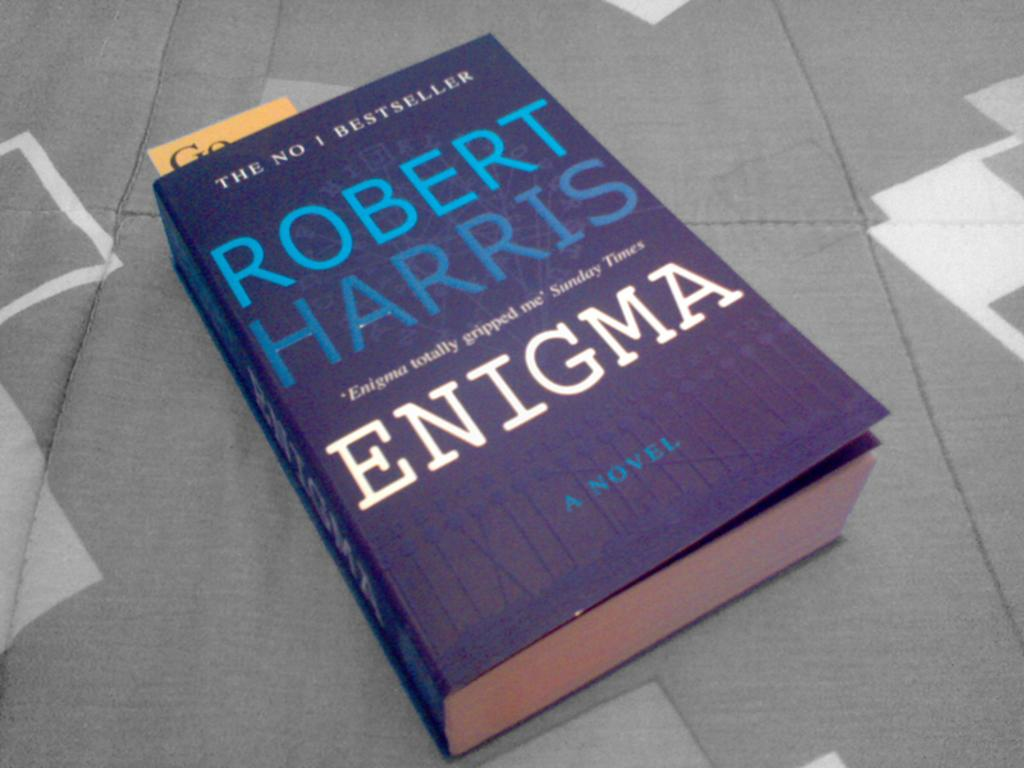<image>
Describe the image concisely. A blue book called Enigma by Robert Harris. 